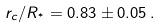Convert formula to latex. <formula><loc_0><loc_0><loc_500><loc_500>r _ { c } / R _ { ^ { * } } = 0 . 8 3 \pm 0 . 0 5 \, .</formula> 